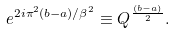<formula> <loc_0><loc_0><loc_500><loc_500>e ^ { 2 i \pi ^ { 2 } ( b - a ) / \beta ^ { 2 } } \equiv Q ^ { \frac { ( b - a ) } { 2 } } .</formula> 